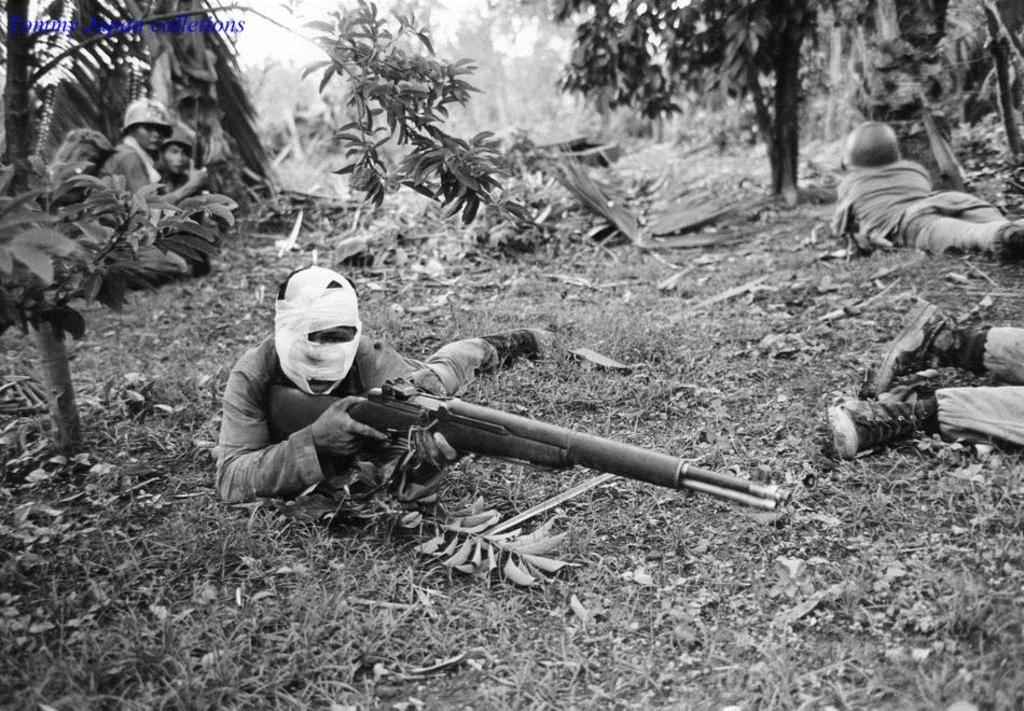What is the color scheme of the image? The image is black and white. What are the people in the image holding? The people are holding guns in their hands. Where are the people located in the image? The people are laying on land in the image. What can be seen in the background of the image? There are trees in the background of the image. How long does it take for the knot to be untied in the image? There is no knot present in the image, so it is not possible to determine how long it would take to untie it. 